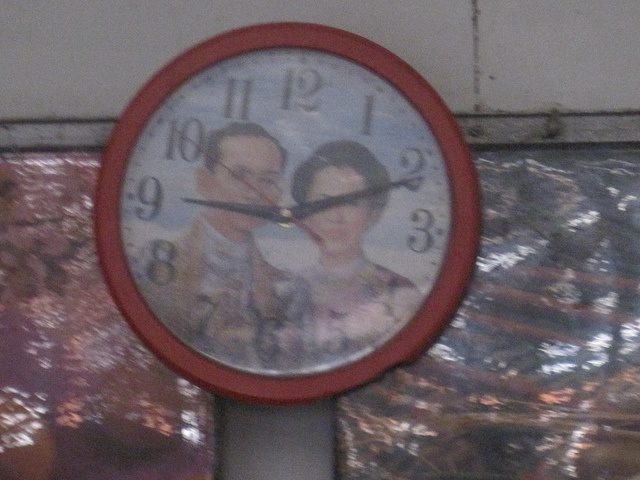Describe the objects in this image and their specific colors. I can see clock in gray and maroon tones, people in gray tones, and people in gray tones in this image. 